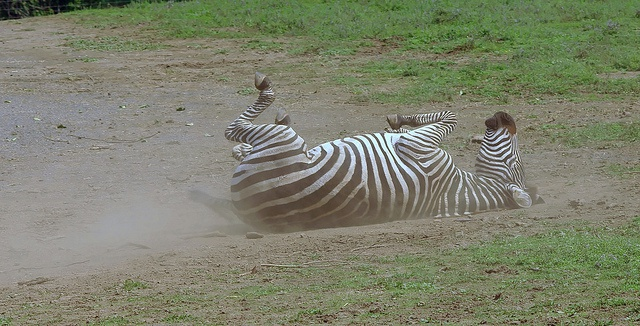Describe the objects in this image and their specific colors. I can see a zebra in black, gray, darkgray, and lightgray tones in this image. 